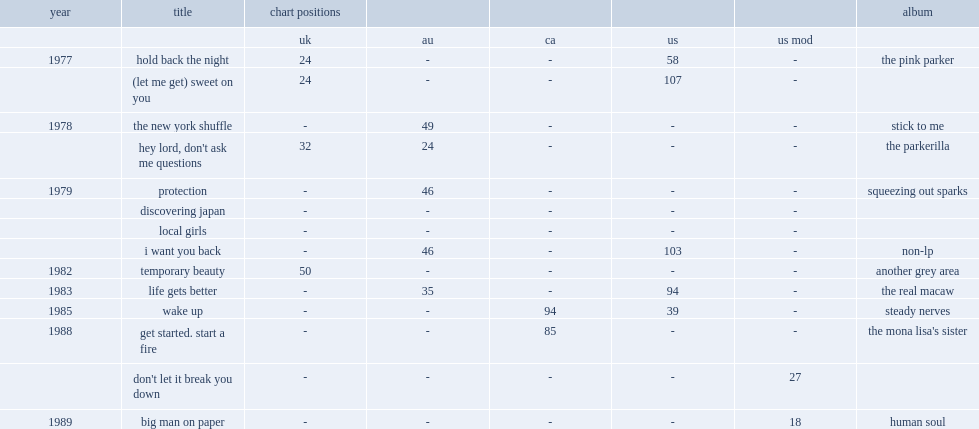When did "wake up (next to you)" release? 1985.0. 